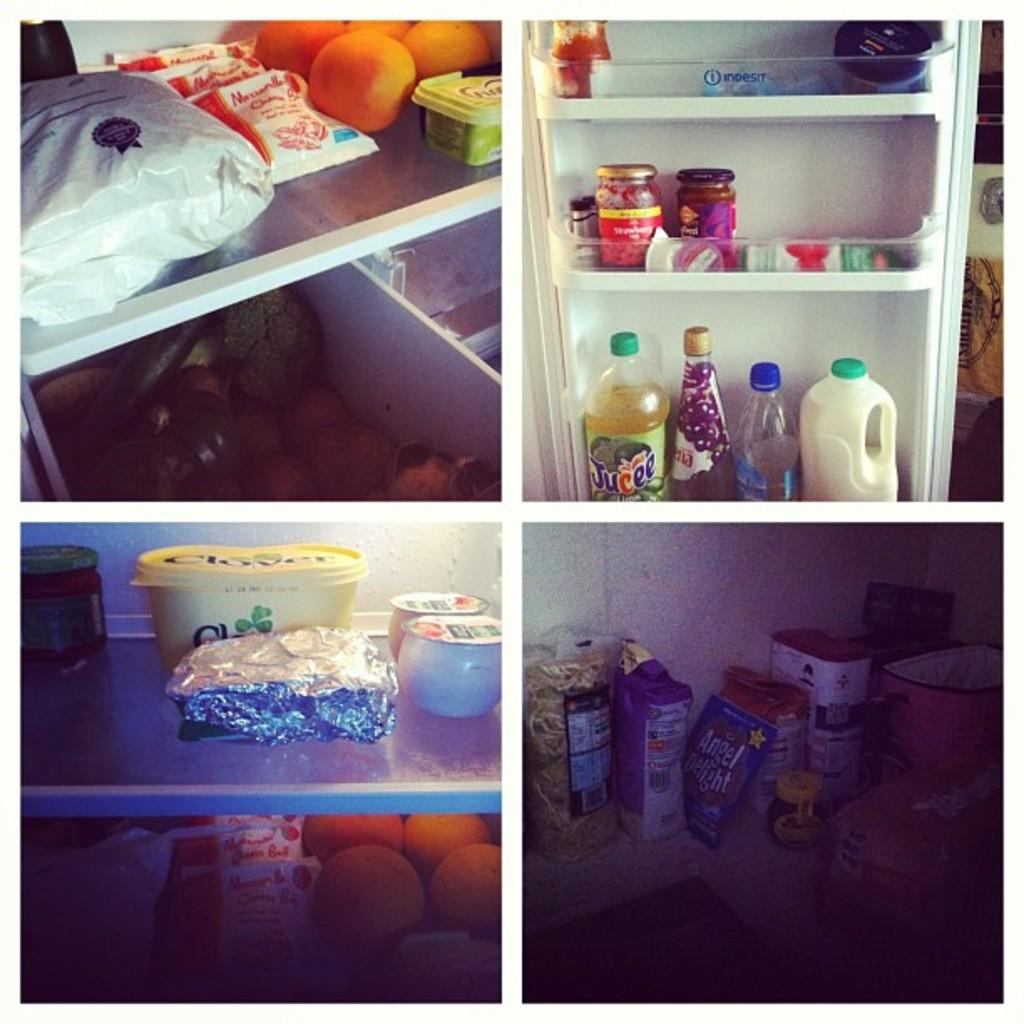What type of containers can be seen in the image? There are bottles in the image. What other types of items are visible in the image? There are grocery products and fruits in the image. Can you describe the other items in the image? There are other items in the image, but their specific nature is not mentioned in the facts. Where are all these items located? All of these items are inside a refrigerator. What type of ear is visible in the image? There is no ear present in the image; it features bottles, grocery products, fruits, and other items inside a refrigerator. How does the cast affect the visibility of the items in the image? There is no cast present in the image, so it does not affect the visibility of the items. 